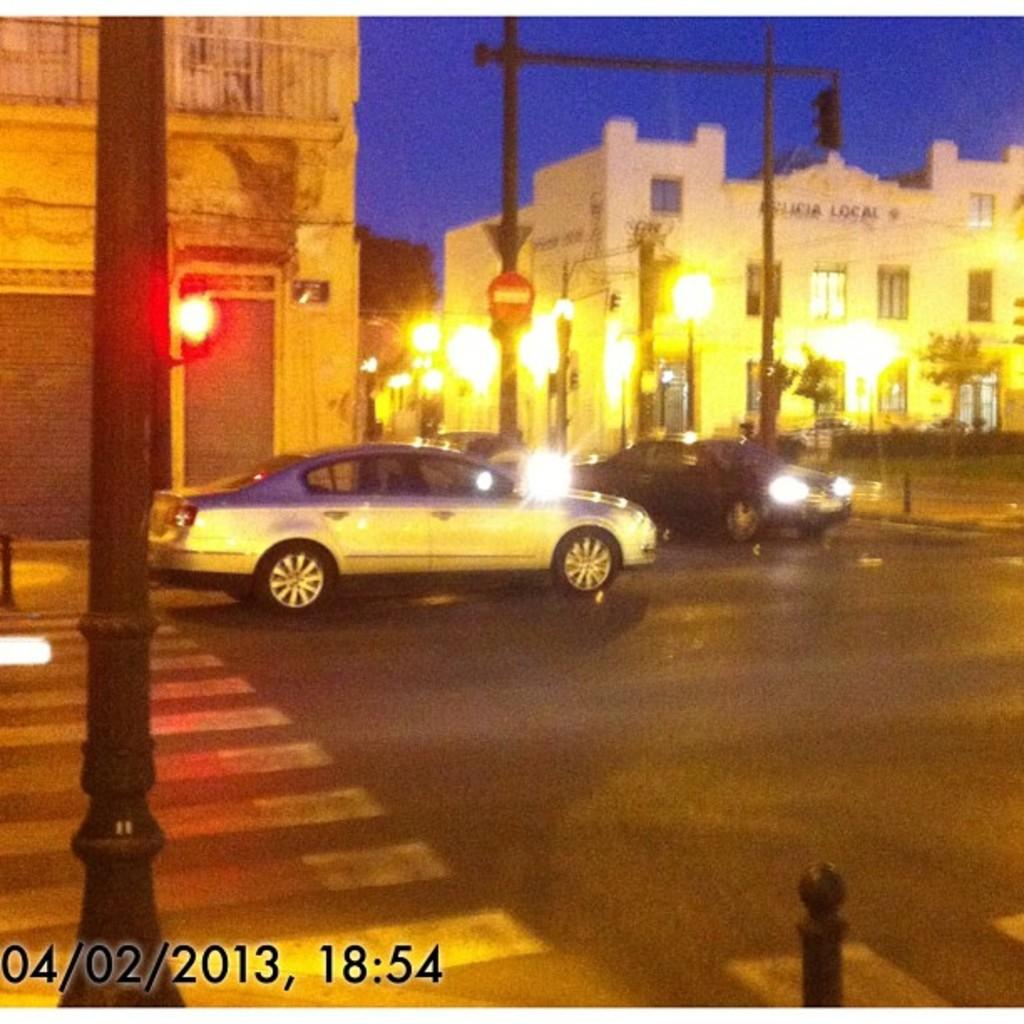<image>
Summarize the visual content of the image. a car on the street on April 2nd 2013 